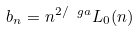Convert formula to latex. <formula><loc_0><loc_0><loc_500><loc_500>b _ { n } = n ^ { 2 / \ g a } L _ { 0 } ( n )</formula> 